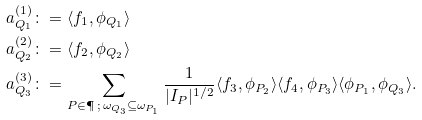<formula> <loc_0><loc_0><loc_500><loc_500>a ^ { ( 1 ) } _ { Q _ { 1 } } & \colon = \langle f _ { 1 } , \phi _ { Q _ { 1 } } \rangle \\ a ^ { ( 2 ) } _ { Q _ { 2 } } & \colon = \langle f _ { 2 } , \phi _ { Q _ { 2 } } \rangle \\ a ^ { ( 3 ) } _ { Q _ { 3 } } & \colon = \sum _ { P \in \P \, ; \, \omega _ { Q _ { 3 } } \subseteq \omega _ { P _ { 1 } } } \frac { 1 } { | I _ { P } | ^ { 1 / 2 } } \langle f _ { 3 } , \phi _ { P _ { 2 } } \rangle \langle f _ { 4 } , \phi _ { P _ { 3 } } \rangle \langle \phi _ { P _ { 1 } } , \phi _ { Q _ { 3 } } \rangle .</formula> 